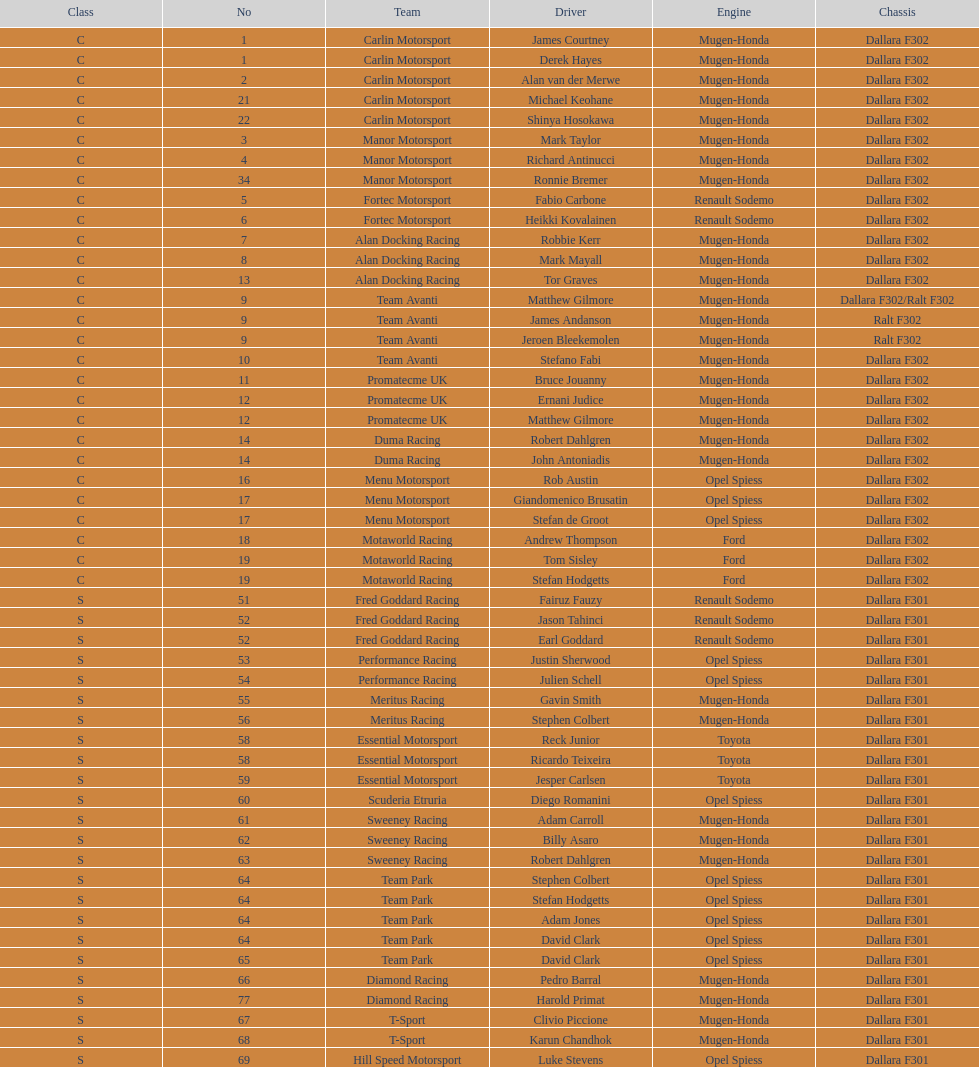Can you parse all the data within this table? {'header': ['Class', 'No', 'Team', 'Driver', 'Engine', 'Chassis'], 'rows': [['C', '1', 'Carlin Motorsport', 'James Courtney', 'Mugen-Honda', 'Dallara F302'], ['C', '1', 'Carlin Motorsport', 'Derek Hayes', 'Mugen-Honda', 'Dallara F302'], ['C', '2', 'Carlin Motorsport', 'Alan van der Merwe', 'Mugen-Honda', 'Dallara F302'], ['C', '21', 'Carlin Motorsport', 'Michael Keohane', 'Mugen-Honda', 'Dallara F302'], ['C', '22', 'Carlin Motorsport', 'Shinya Hosokawa', 'Mugen-Honda', 'Dallara F302'], ['C', '3', 'Manor Motorsport', 'Mark Taylor', 'Mugen-Honda', 'Dallara F302'], ['C', '4', 'Manor Motorsport', 'Richard Antinucci', 'Mugen-Honda', 'Dallara F302'], ['C', '34', 'Manor Motorsport', 'Ronnie Bremer', 'Mugen-Honda', 'Dallara F302'], ['C', '5', 'Fortec Motorsport', 'Fabio Carbone', 'Renault Sodemo', 'Dallara F302'], ['C', '6', 'Fortec Motorsport', 'Heikki Kovalainen', 'Renault Sodemo', 'Dallara F302'], ['C', '7', 'Alan Docking Racing', 'Robbie Kerr', 'Mugen-Honda', 'Dallara F302'], ['C', '8', 'Alan Docking Racing', 'Mark Mayall', 'Mugen-Honda', 'Dallara F302'], ['C', '13', 'Alan Docking Racing', 'Tor Graves', 'Mugen-Honda', 'Dallara F302'], ['C', '9', 'Team Avanti', 'Matthew Gilmore', 'Mugen-Honda', 'Dallara F302/Ralt F302'], ['C', '9', 'Team Avanti', 'James Andanson', 'Mugen-Honda', 'Ralt F302'], ['C', '9', 'Team Avanti', 'Jeroen Bleekemolen', 'Mugen-Honda', 'Ralt F302'], ['C', '10', 'Team Avanti', 'Stefano Fabi', 'Mugen-Honda', 'Dallara F302'], ['C', '11', 'Promatecme UK', 'Bruce Jouanny', 'Mugen-Honda', 'Dallara F302'], ['C', '12', 'Promatecme UK', 'Ernani Judice', 'Mugen-Honda', 'Dallara F302'], ['C', '12', 'Promatecme UK', 'Matthew Gilmore', 'Mugen-Honda', 'Dallara F302'], ['C', '14', 'Duma Racing', 'Robert Dahlgren', 'Mugen-Honda', 'Dallara F302'], ['C', '14', 'Duma Racing', 'John Antoniadis', 'Mugen-Honda', 'Dallara F302'], ['C', '16', 'Menu Motorsport', 'Rob Austin', 'Opel Spiess', 'Dallara F302'], ['C', '17', 'Menu Motorsport', 'Giandomenico Brusatin', 'Opel Spiess', 'Dallara F302'], ['C', '17', 'Menu Motorsport', 'Stefan de Groot', 'Opel Spiess', 'Dallara F302'], ['C', '18', 'Motaworld Racing', 'Andrew Thompson', 'Ford', 'Dallara F302'], ['C', '19', 'Motaworld Racing', 'Tom Sisley', 'Ford', 'Dallara F302'], ['C', '19', 'Motaworld Racing', 'Stefan Hodgetts', 'Ford', 'Dallara F302'], ['S', '51', 'Fred Goddard Racing', 'Fairuz Fauzy', 'Renault Sodemo', 'Dallara F301'], ['S', '52', 'Fred Goddard Racing', 'Jason Tahinci', 'Renault Sodemo', 'Dallara F301'], ['S', '52', 'Fred Goddard Racing', 'Earl Goddard', 'Renault Sodemo', 'Dallara F301'], ['S', '53', 'Performance Racing', 'Justin Sherwood', 'Opel Spiess', 'Dallara F301'], ['S', '54', 'Performance Racing', 'Julien Schell', 'Opel Spiess', 'Dallara F301'], ['S', '55', 'Meritus Racing', 'Gavin Smith', 'Mugen-Honda', 'Dallara F301'], ['S', '56', 'Meritus Racing', 'Stephen Colbert', 'Mugen-Honda', 'Dallara F301'], ['S', '58', 'Essential Motorsport', 'Reck Junior', 'Toyota', 'Dallara F301'], ['S', '58', 'Essential Motorsport', 'Ricardo Teixeira', 'Toyota', 'Dallara F301'], ['S', '59', 'Essential Motorsport', 'Jesper Carlsen', 'Toyota', 'Dallara F301'], ['S', '60', 'Scuderia Etruria', 'Diego Romanini', 'Opel Spiess', 'Dallara F301'], ['S', '61', 'Sweeney Racing', 'Adam Carroll', 'Mugen-Honda', 'Dallara F301'], ['S', '62', 'Sweeney Racing', 'Billy Asaro', 'Mugen-Honda', 'Dallara F301'], ['S', '63', 'Sweeney Racing', 'Robert Dahlgren', 'Mugen-Honda', 'Dallara F301'], ['S', '64', 'Team Park', 'Stephen Colbert', 'Opel Spiess', 'Dallara F301'], ['S', '64', 'Team Park', 'Stefan Hodgetts', 'Opel Spiess', 'Dallara F301'], ['S', '64', 'Team Park', 'Adam Jones', 'Opel Spiess', 'Dallara F301'], ['S', '64', 'Team Park', 'David Clark', 'Opel Spiess', 'Dallara F301'], ['S', '65', 'Team Park', 'David Clark', 'Opel Spiess', 'Dallara F301'], ['S', '66', 'Diamond Racing', 'Pedro Barral', 'Mugen-Honda', 'Dallara F301'], ['S', '77', 'Diamond Racing', 'Harold Primat', 'Mugen-Honda', 'Dallara F301'], ['S', '67', 'T-Sport', 'Clivio Piccione', 'Mugen-Honda', 'Dallara F301'], ['S', '68', 'T-Sport', 'Karun Chandhok', 'Mugen-Honda', 'Dallara F301'], ['S', '69', 'Hill Speed Motorsport', 'Luke Stevens', 'Opel Spiess', 'Dallara F301']]} How many class s (scholarship) teams are on the chart? 19. 